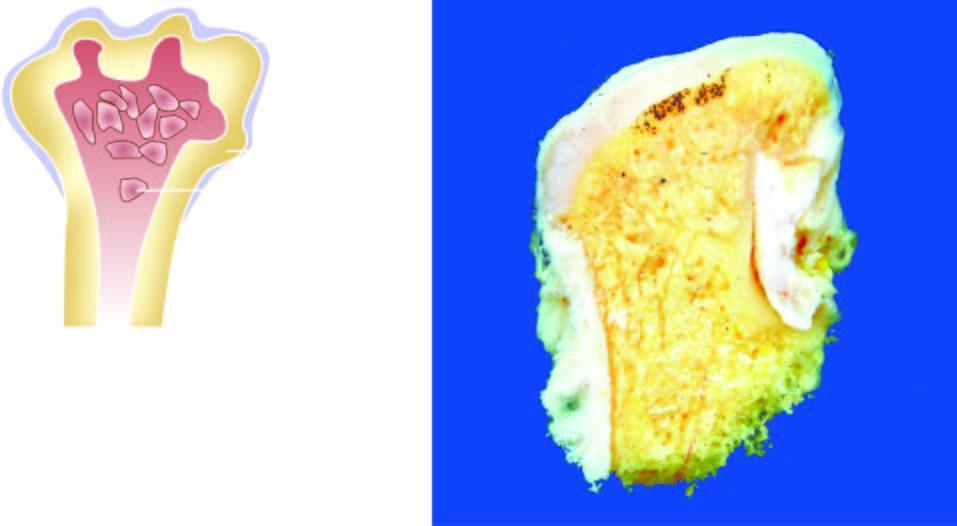do these granulomas have cartilaginous caps and inner osseous tissue?
Answer the question using a single word or phrase. No 